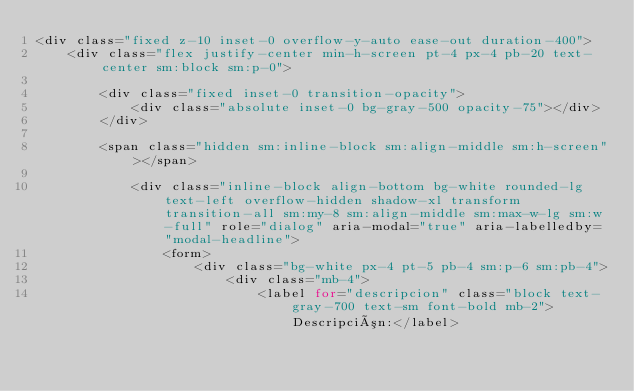Convert code to text. <code><loc_0><loc_0><loc_500><loc_500><_PHP_><div class="fixed z-10 inset-0 overflow-y-auto ease-out duration-400">
    <div class="flex justify-center min-h-screen pt-4 px-4 pb-20 text-center sm:block sm:p-0">
    
        <div class="fixed inset-0 transition-opacity">
            <div class="absolute inset-0 bg-gray-500 opacity-75"></div>
        </div>

        <span class="hidden sm:inline-block sm:align-middle sm:h-screen"></span>

            <div class="inline-block align-bottom bg-white rounded-lg text-left overflow-hidden shadow-xl transform transition-all sm:my-8 sm:align-middle sm:max-w-lg sm:w-full" role="dialog" aria-modal="true" aria-labelledby="modal-headline">    
                <form>
                    <div class="bg-white px-4 pt-5 pb-4 sm:p-6 sm:pb-4">
                        <div class="mb-4">
                            <label for="descripcion" class="block text-gray-700 text-sm font-bold mb-2">Descripción:</label></code> 